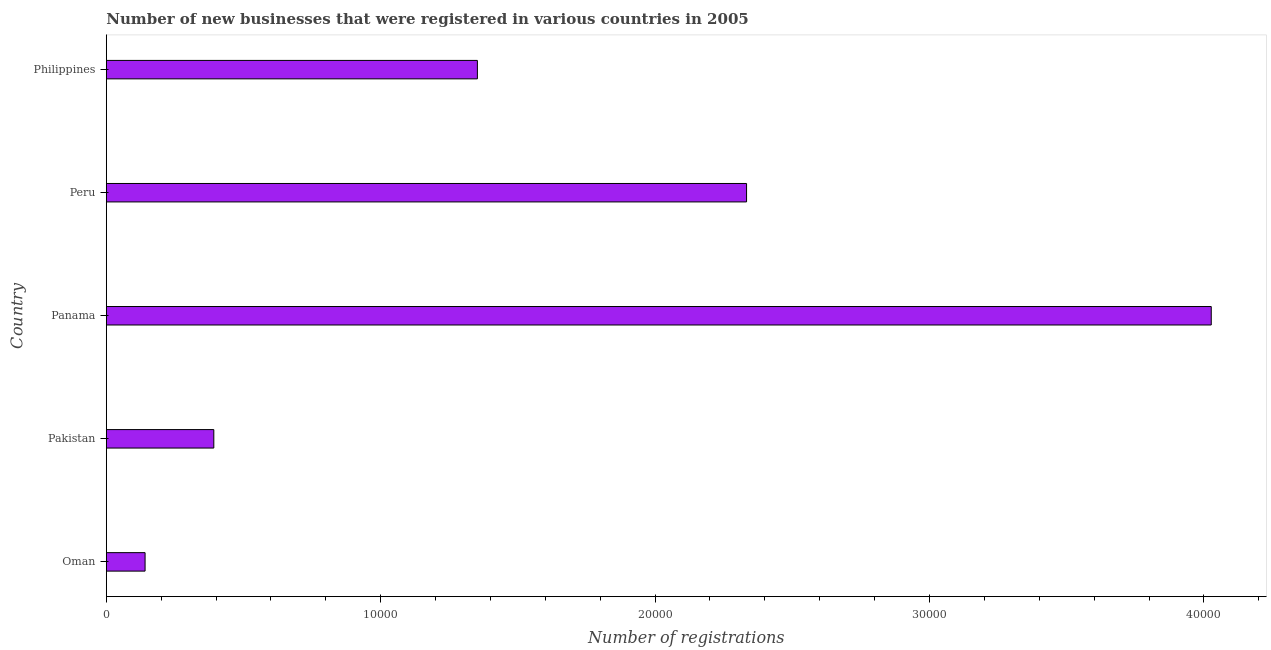What is the title of the graph?
Your answer should be very brief. Number of new businesses that were registered in various countries in 2005. What is the label or title of the X-axis?
Provide a short and direct response. Number of registrations. What is the number of new business registrations in Peru?
Offer a terse response. 2.33e+04. Across all countries, what is the maximum number of new business registrations?
Your response must be concise. 4.03e+04. Across all countries, what is the minimum number of new business registrations?
Provide a succinct answer. 1412. In which country was the number of new business registrations maximum?
Offer a terse response. Panama. In which country was the number of new business registrations minimum?
Your answer should be compact. Oman. What is the sum of the number of new business registrations?
Keep it short and to the point. 8.25e+04. What is the difference between the number of new business registrations in Peru and Philippines?
Give a very brief answer. 9810. What is the average number of new business registrations per country?
Make the answer very short. 1.65e+04. What is the median number of new business registrations?
Make the answer very short. 1.35e+04. What is the ratio of the number of new business registrations in Panama to that in Philippines?
Offer a very short reply. 2.98. Is the number of new business registrations in Pakistan less than that in Peru?
Provide a succinct answer. Yes. What is the difference between the highest and the second highest number of new business registrations?
Make the answer very short. 1.69e+04. What is the difference between the highest and the lowest number of new business registrations?
Ensure brevity in your answer.  3.89e+04. In how many countries, is the number of new business registrations greater than the average number of new business registrations taken over all countries?
Your answer should be compact. 2. What is the Number of registrations in Oman?
Your answer should be very brief. 1412. What is the Number of registrations in Pakistan?
Keep it short and to the point. 3917. What is the Number of registrations in Panama?
Give a very brief answer. 4.03e+04. What is the Number of registrations in Peru?
Make the answer very short. 2.33e+04. What is the Number of registrations in Philippines?
Keep it short and to the point. 1.35e+04. What is the difference between the Number of registrations in Oman and Pakistan?
Offer a very short reply. -2505. What is the difference between the Number of registrations in Oman and Panama?
Keep it short and to the point. -3.89e+04. What is the difference between the Number of registrations in Oman and Peru?
Give a very brief answer. -2.19e+04. What is the difference between the Number of registrations in Oman and Philippines?
Offer a terse response. -1.21e+04. What is the difference between the Number of registrations in Pakistan and Panama?
Make the answer very short. -3.64e+04. What is the difference between the Number of registrations in Pakistan and Peru?
Your answer should be compact. -1.94e+04. What is the difference between the Number of registrations in Pakistan and Philippines?
Ensure brevity in your answer.  -9606. What is the difference between the Number of registrations in Panama and Peru?
Offer a very short reply. 1.69e+04. What is the difference between the Number of registrations in Panama and Philippines?
Your answer should be compact. 2.67e+04. What is the difference between the Number of registrations in Peru and Philippines?
Keep it short and to the point. 9810. What is the ratio of the Number of registrations in Oman to that in Pakistan?
Provide a short and direct response. 0.36. What is the ratio of the Number of registrations in Oman to that in Panama?
Offer a terse response. 0.04. What is the ratio of the Number of registrations in Oman to that in Peru?
Your answer should be compact. 0.06. What is the ratio of the Number of registrations in Oman to that in Philippines?
Provide a short and direct response. 0.1. What is the ratio of the Number of registrations in Pakistan to that in Panama?
Keep it short and to the point. 0.1. What is the ratio of the Number of registrations in Pakistan to that in Peru?
Provide a succinct answer. 0.17. What is the ratio of the Number of registrations in Pakistan to that in Philippines?
Make the answer very short. 0.29. What is the ratio of the Number of registrations in Panama to that in Peru?
Offer a very short reply. 1.73. What is the ratio of the Number of registrations in Panama to that in Philippines?
Keep it short and to the point. 2.98. What is the ratio of the Number of registrations in Peru to that in Philippines?
Ensure brevity in your answer.  1.73. 